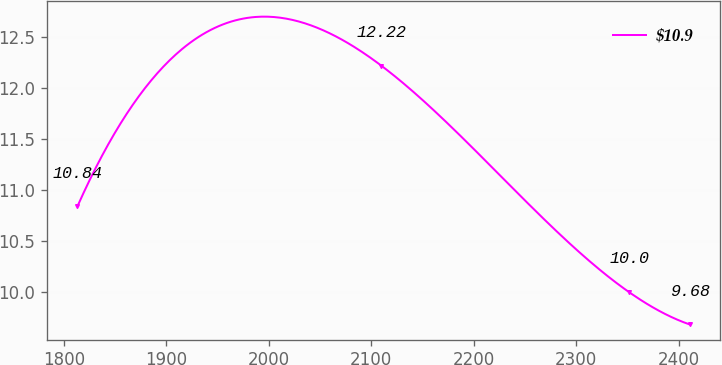<chart> <loc_0><loc_0><loc_500><loc_500><line_chart><ecel><fcel>$10.9<nl><fcel>1813.26<fcel>10.84<nl><fcel>2109.78<fcel>12.22<nl><fcel>2351.05<fcel>10<nl><fcel>2410.55<fcel>9.68<nl></chart> 